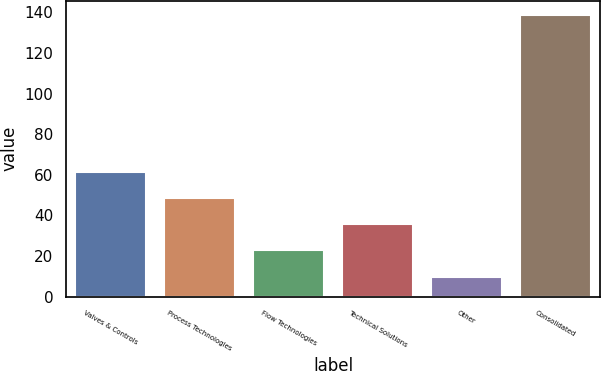<chart> <loc_0><loc_0><loc_500><loc_500><bar_chart><fcel>Valves & Controls<fcel>Process Technologies<fcel>Flow Technologies<fcel>Technical Solutions<fcel>Other<fcel>Consolidated<nl><fcel>61.42<fcel>48.54<fcel>22.78<fcel>35.66<fcel>9.9<fcel>138.7<nl></chart> 